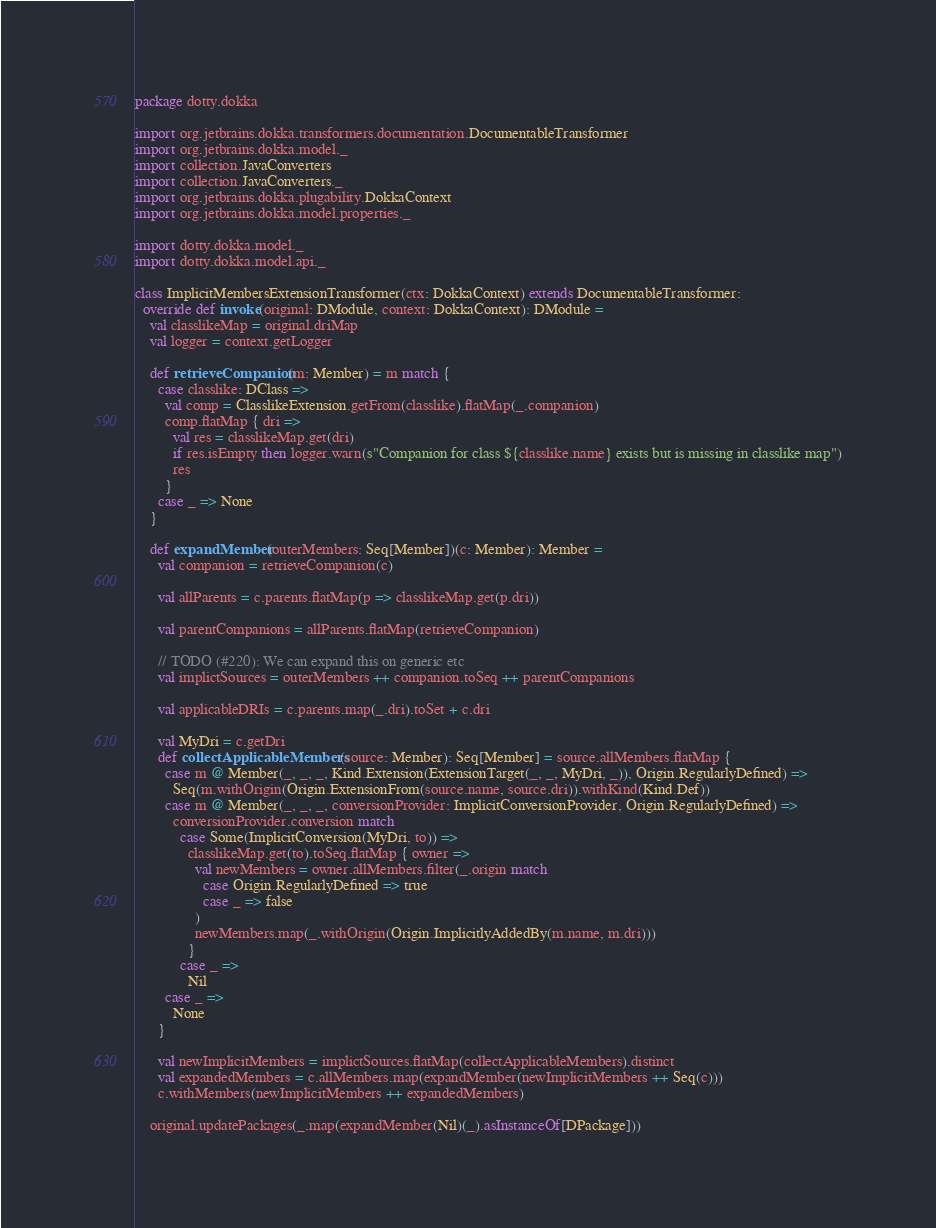<code> <loc_0><loc_0><loc_500><loc_500><_Scala_>package dotty.dokka

import org.jetbrains.dokka.transformers.documentation.DocumentableTransformer
import org.jetbrains.dokka.model._
import collection.JavaConverters
import collection.JavaConverters._
import org.jetbrains.dokka.plugability.DokkaContext
import org.jetbrains.dokka.model.properties._

import dotty.dokka.model._
import dotty.dokka.model.api._

class ImplicitMembersExtensionTransformer(ctx: DokkaContext) extends DocumentableTransformer:
  override def invoke(original: DModule, context: DokkaContext): DModule =
    val classlikeMap = original.driMap
    val logger = context.getLogger

    def retrieveCompanion(m: Member) = m match {
      case classlike: DClass =>
        val comp = ClasslikeExtension.getFrom(classlike).flatMap(_.companion)
        comp.flatMap { dri =>
          val res = classlikeMap.get(dri)
          if res.isEmpty then logger.warn(s"Companion for class ${classlike.name} exists but is missing in classlike map")
          res
        }
      case _ => None
    }

    def expandMember(outerMembers: Seq[Member])(c: Member): Member =
      val companion = retrieveCompanion(c)

      val allParents = c.parents.flatMap(p => classlikeMap.get(p.dri))

      val parentCompanions = allParents.flatMap(retrieveCompanion)

      // TODO (#220): We can expand this on generic etc
      val implictSources = outerMembers ++ companion.toSeq ++ parentCompanions

      val applicableDRIs = c.parents.map(_.dri).toSet + c.dri

      val MyDri = c.getDri
      def collectApplicableMembers(source: Member): Seq[Member] = source.allMembers.flatMap {
        case m @ Member(_, _, _, Kind.Extension(ExtensionTarget(_, _, MyDri, _)), Origin.RegularlyDefined) =>
          Seq(m.withOrigin(Origin.ExtensionFrom(source.name, source.dri)).withKind(Kind.Def))
        case m @ Member(_, _, _, conversionProvider: ImplicitConversionProvider, Origin.RegularlyDefined) =>
          conversionProvider.conversion match
            case Some(ImplicitConversion(MyDri, to)) =>
              classlikeMap.get(to).toSeq.flatMap { owner =>
                val newMembers = owner.allMembers.filter(_.origin match
                  case Origin.RegularlyDefined => true
                  case _ => false
                )
                newMembers.map(_.withOrigin(Origin.ImplicitlyAddedBy(m.name, m.dri)))
              }
            case _ =>
              Nil
        case _ =>
          None
      }

      val newImplicitMembers = implictSources.flatMap(collectApplicableMembers).distinct
      val expandedMembers = c.allMembers.map(expandMember(newImplicitMembers ++ Seq(c)))
      c.withMembers(newImplicitMembers ++ expandedMembers)

    original.updatePackages(_.map(expandMember(Nil)(_).asInstanceOf[DPackage]))
</code> 